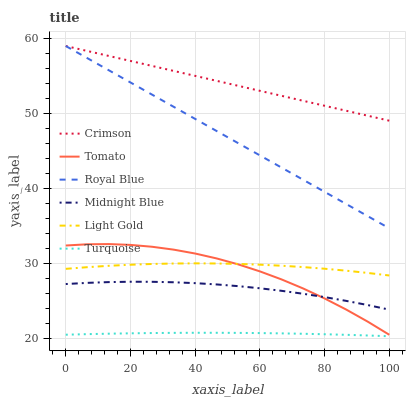Does Midnight Blue have the minimum area under the curve?
Answer yes or no. No. Does Midnight Blue have the maximum area under the curve?
Answer yes or no. No. Is Turquoise the smoothest?
Answer yes or no. No. Is Turquoise the roughest?
Answer yes or no. No. Does Midnight Blue have the lowest value?
Answer yes or no. No. Does Midnight Blue have the highest value?
Answer yes or no. No. Is Midnight Blue less than Light Gold?
Answer yes or no. Yes. Is Royal Blue greater than Midnight Blue?
Answer yes or no. Yes. Does Midnight Blue intersect Light Gold?
Answer yes or no. No. 